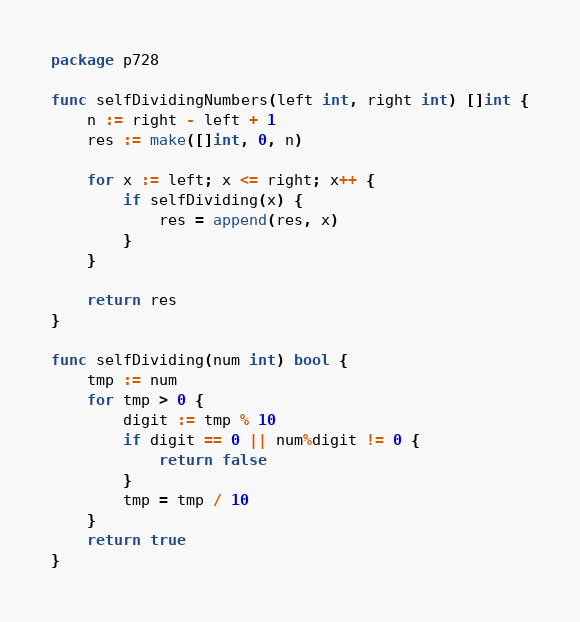Convert code to text. <code><loc_0><loc_0><loc_500><loc_500><_Go_>package p728

func selfDividingNumbers(left int, right int) []int {
	n := right - left + 1
	res := make([]int, 0, n)

	for x := left; x <= right; x++ {
		if selfDividing(x) {
			res = append(res, x)
		}
	}

	return res
}

func selfDividing(num int) bool {
	tmp := num
	for tmp > 0 {
		digit := tmp % 10
		if digit == 0 || num%digit != 0 {
			return false
		}
		tmp = tmp / 10
	}
	return true
}
</code> 